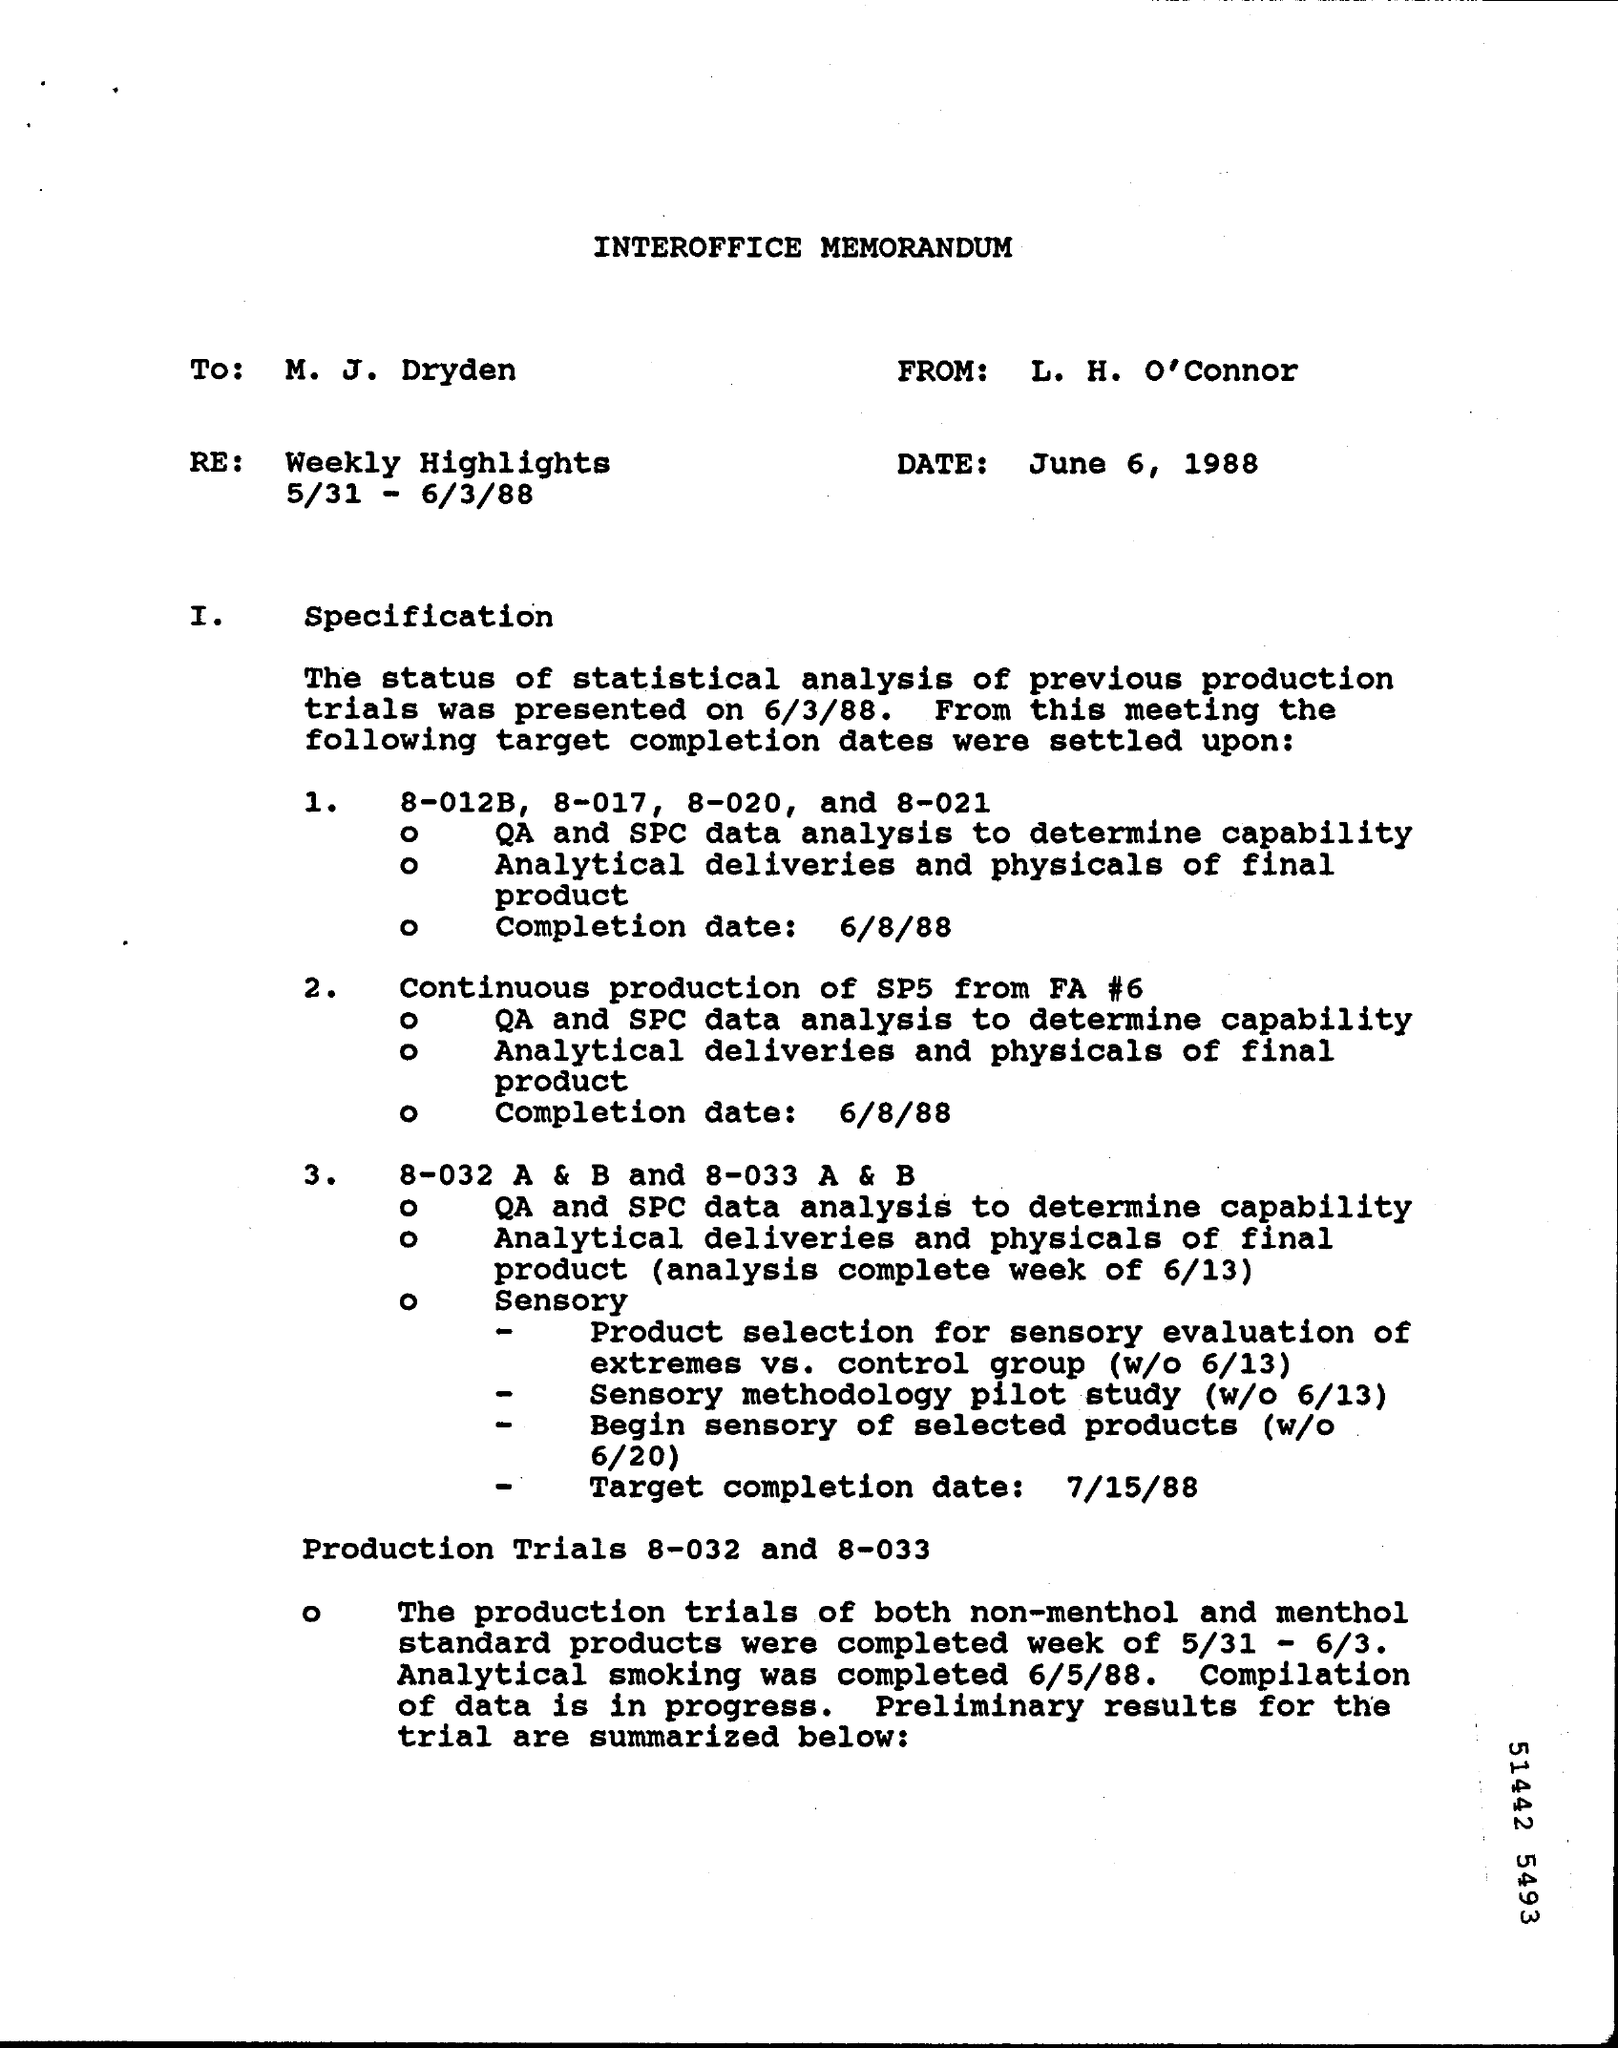Who is the memorandum from?
Provide a short and direct response. L. H. O'Connor. What is the Date?
Your answer should be compact. June 6, 1988. What is the Re:?
Your answer should be very brief. Weekly Highlights 5/31 - 6/3/88. 